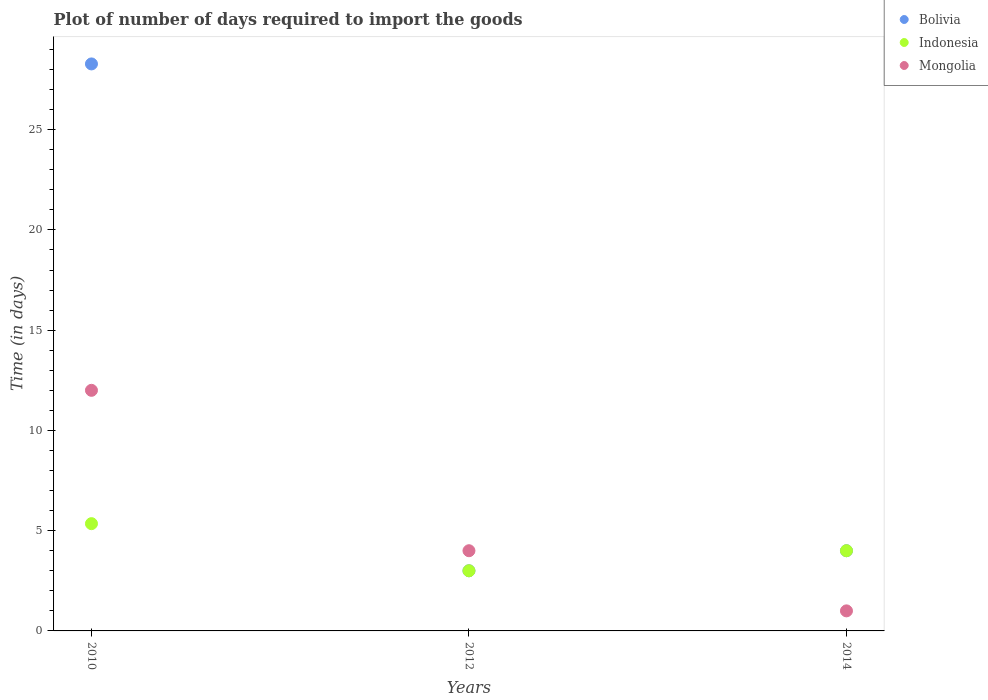How many different coloured dotlines are there?
Your answer should be very brief. 3. Is the number of dotlines equal to the number of legend labels?
Provide a succinct answer. Yes. Across all years, what is the minimum time required to import goods in Mongolia?
Provide a succinct answer. 1. What is the total time required to import goods in Mongolia in the graph?
Keep it short and to the point. 17. What is the difference between the time required to import goods in Indonesia in 2010 and that in 2014?
Your answer should be compact. 1.35. What is the difference between the time required to import goods in Indonesia in 2014 and the time required to import goods in Bolivia in 2012?
Your answer should be very brief. 1. What is the average time required to import goods in Indonesia per year?
Provide a short and direct response. 4.12. In the year 2012, what is the difference between the time required to import goods in Mongolia and time required to import goods in Indonesia?
Your answer should be very brief. 1. What is the difference between the highest and the second highest time required to import goods in Bolivia?
Give a very brief answer. 24.28. What is the difference between the highest and the lowest time required to import goods in Bolivia?
Your response must be concise. 25.28. Is the sum of the time required to import goods in Bolivia in 2010 and 2012 greater than the maximum time required to import goods in Indonesia across all years?
Make the answer very short. Yes. Is it the case that in every year, the sum of the time required to import goods in Indonesia and time required to import goods in Mongolia  is greater than the time required to import goods in Bolivia?
Make the answer very short. No. Does the time required to import goods in Mongolia monotonically increase over the years?
Offer a very short reply. No. Is the time required to import goods in Mongolia strictly greater than the time required to import goods in Indonesia over the years?
Your answer should be compact. No. Is the time required to import goods in Mongolia strictly less than the time required to import goods in Bolivia over the years?
Your answer should be compact. No. What is the difference between two consecutive major ticks on the Y-axis?
Provide a short and direct response. 5. Does the graph contain grids?
Offer a terse response. No. What is the title of the graph?
Give a very brief answer. Plot of number of days required to import the goods. Does "Vietnam" appear as one of the legend labels in the graph?
Give a very brief answer. No. What is the label or title of the X-axis?
Provide a short and direct response. Years. What is the label or title of the Y-axis?
Your answer should be compact. Time (in days). What is the Time (in days) in Bolivia in 2010?
Your answer should be very brief. 28.28. What is the Time (in days) in Indonesia in 2010?
Make the answer very short. 5.35. What is the Time (in days) in Mongolia in 2010?
Offer a very short reply. 12. What is the Time (in days) in Indonesia in 2012?
Your response must be concise. 3. What is the Time (in days) of Mongolia in 2012?
Provide a short and direct response. 4. What is the Time (in days) of Bolivia in 2014?
Your response must be concise. 4. What is the Time (in days) in Indonesia in 2014?
Offer a very short reply. 4. What is the Time (in days) in Mongolia in 2014?
Your response must be concise. 1. Across all years, what is the maximum Time (in days) in Bolivia?
Ensure brevity in your answer.  28.28. Across all years, what is the maximum Time (in days) of Indonesia?
Provide a short and direct response. 5.35. Across all years, what is the maximum Time (in days) in Mongolia?
Your answer should be compact. 12. Across all years, what is the minimum Time (in days) of Bolivia?
Keep it short and to the point. 3. Across all years, what is the minimum Time (in days) in Indonesia?
Provide a succinct answer. 3. What is the total Time (in days) in Bolivia in the graph?
Your answer should be very brief. 35.28. What is the total Time (in days) in Indonesia in the graph?
Ensure brevity in your answer.  12.35. What is the total Time (in days) of Mongolia in the graph?
Offer a very short reply. 17. What is the difference between the Time (in days) in Bolivia in 2010 and that in 2012?
Offer a very short reply. 25.28. What is the difference between the Time (in days) in Indonesia in 2010 and that in 2012?
Offer a very short reply. 2.35. What is the difference between the Time (in days) of Bolivia in 2010 and that in 2014?
Make the answer very short. 24.28. What is the difference between the Time (in days) in Indonesia in 2010 and that in 2014?
Make the answer very short. 1.35. What is the difference between the Time (in days) of Mongolia in 2010 and that in 2014?
Make the answer very short. 11. What is the difference between the Time (in days) of Bolivia in 2012 and that in 2014?
Ensure brevity in your answer.  -1. What is the difference between the Time (in days) of Indonesia in 2012 and that in 2014?
Offer a terse response. -1. What is the difference between the Time (in days) in Bolivia in 2010 and the Time (in days) in Indonesia in 2012?
Offer a terse response. 25.28. What is the difference between the Time (in days) in Bolivia in 2010 and the Time (in days) in Mongolia in 2012?
Give a very brief answer. 24.28. What is the difference between the Time (in days) in Indonesia in 2010 and the Time (in days) in Mongolia in 2012?
Keep it short and to the point. 1.35. What is the difference between the Time (in days) in Bolivia in 2010 and the Time (in days) in Indonesia in 2014?
Offer a terse response. 24.28. What is the difference between the Time (in days) of Bolivia in 2010 and the Time (in days) of Mongolia in 2014?
Ensure brevity in your answer.  27.28. What is the difference between the Time (in days) in Indonesia in 2010 and the Time (in days) in Mongolia in 2014?
Your response must be concise. 4.35. What is the difference between the Time (in days) of Indonesia in 2012 and the Time (in days) of Mongolia in 2014?
Your answer should be compact. 2. What is the average Time (in days) of Bolivia per year?
Provide a succinct answer. 11.76. What is the average Time (in days) of Indonesia per year?
Offer a very short reply. 4.12. What is the average Time (in days) of Mongolia per year?
Make the answer very short. 5.67. In the year 2010, what is the difference between the Time (in days) of Bolivia and Time (in days) of Indonesia?
Provide a succinct answer. 22.93. In the year 2010, what is the difference between the Time (in days) in Bolivia and Time (in days) in Mongolia?
Make the answer very short. 16.28. In the year 2010, what is the difference between the Time (in days) of Indonesia and Time (in days) of Mongolia?
Make the answer very short. -6.65. In the year 2012, what is the difference between the Time (in days) in Bolivia and Time (in days) in Indonesia?
Give a very brief answer. 0. In the year 2012, what is the difference between the Time (in days) in Bolivia and Time (in days) in Mongolia?
Your answer should be compact. -1. In the year 2014, what is the difference between the Time (in days) of Bolivia and Time (in days) of Mongolia?
Provide a succinct answer. 3. In the year 2014, what is the difference between the Time (in days) in Indonesia and Time (in days) in Mongolia?
Offer a very short reply. 3. What is the ratio of the Time (in days) in Bolivia in 2010 to that in 2012?
Your response must be concise. 9.43. What is the ratio of the Time (in days) of Indonesia in 2010 to that in 2012?
Offer a very short reply. 1.78. What is the ratio of the Time (in days) in Bolivia in 2010 to that in 2014?
Provide a short and direct response. 7.07. What is the ratio of the Time (in days) in Indonesia in 2010 to that in 2014?
Keep it short and to the point. 1.34. What is the ratio of the Time (in days) in Mongolia in 2010 to that in 2014?
Offer a very short reply. 12. What is the ratio of the Time (in days) of Bolivia in 2012 to that in 2014?
Keep it short and to the point. 0.75. What is the ratio of the Time (in days) of Indonesia in 2012 to that in 2014?
Ensure brevity in your answer.  0.75. What is the ratio of the Time (in days) in Mongolia in 2012 to that in 2014?
Your answer should be very brief. 4. What is the difference between the highest and the second highest Time (in days) of Bolivia?
Give a very brief answer. 24.28. What is the difference between the highest and the second highest Time (in days) in Indonesia?
Make the answer very short. 1.35. What is the difference between the highest and the second highest Time (in days) of Mongolia?
Keep it short and to the point. 8. What is the difference between the highest and the lowest Time (in days) in Bolivia?
Ensure brevity in your answer.  25.28. What is the difference between the highest and the lowest Time (in days) of Indonesia?
Ensure brevity in your answer.  2.35. What is the difference between the highest and the lowest Time (in days) in Mongolia?
Give a very brief answer. 11. 